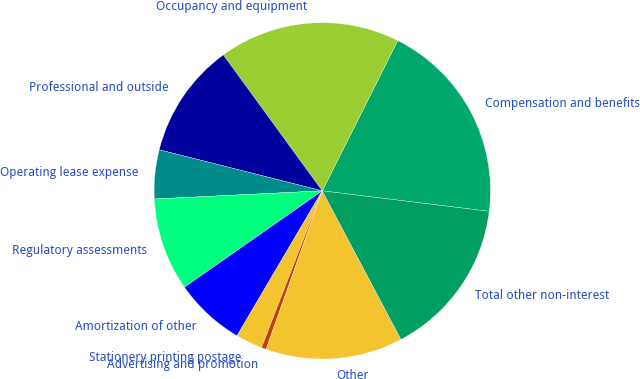<chart> <loc_0><loc_0><loc_500><loc_500><pie_chart><fcel>Compensation and benefits<fcel>Occupancy and equipment<fcel>Professional and outside<fcel>Operating lease expense<fcel>Regulatory assessments<fcel>Amortization of other<fcel>Stationery printing postage<fcel>Advertising and promotion<fcel>Other<fcel>Total other non-interest<nl><fcel>19.54%<fcel>17.42%<fcel>11.06%<fcel>4.7%<fcel>8.94%<fcel>6.82%<fcel>2.58%<fcel>0.46%<fcel>13.18%<fcel>15.3%<nl></chart> 